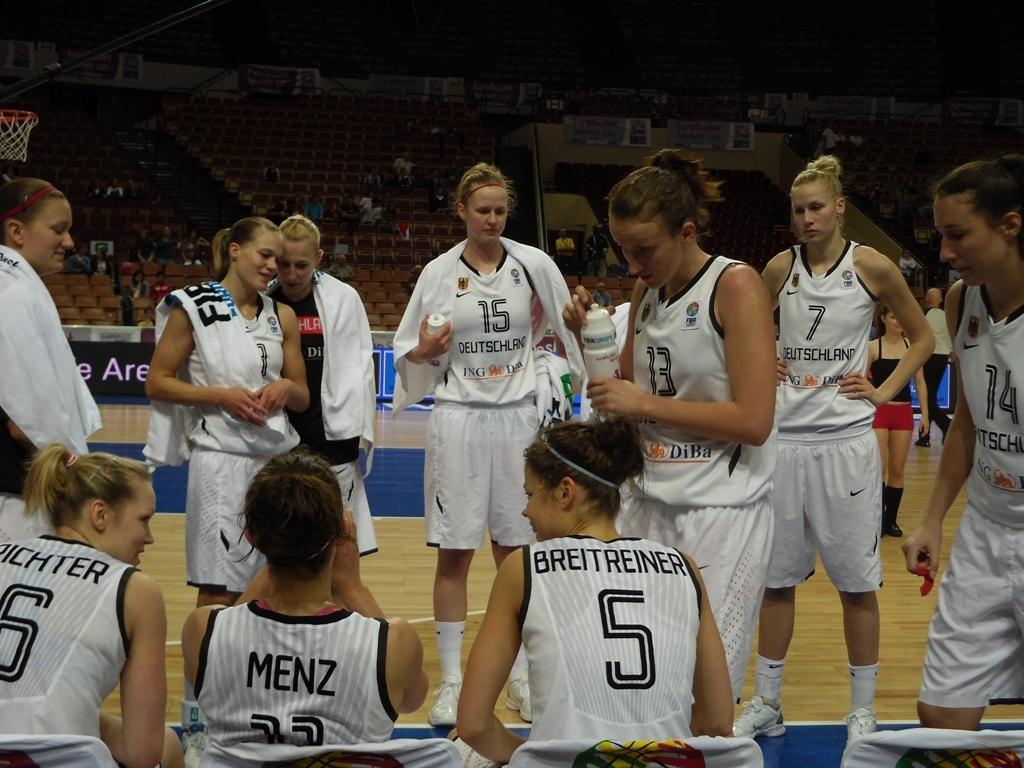What is the jersey number of the girl on the far right?
Your response must be concise. 14. 